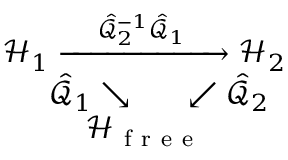Convert formula to latex. <formula><loc_0><loc_0><loc_500><loc_500>\begin{array} { r } { \mathcal { H } _ { 1 } \xrightarrow { \, \hat { \mathcal { Q } } _ { 2 } ^ { - 1 } \hat { \mathcal { Q } } _ { 1 } \, } \mathcal { H } _ { 2 } } \\ { \hat { \mathcal { Q } } _ { 1 } \searrow \, \swarrow \hat { \mathcal { Q } } _ { 2 } \, } \\ { \mathcal { H } _ { f r e e } \, } \end{array}</formula> 